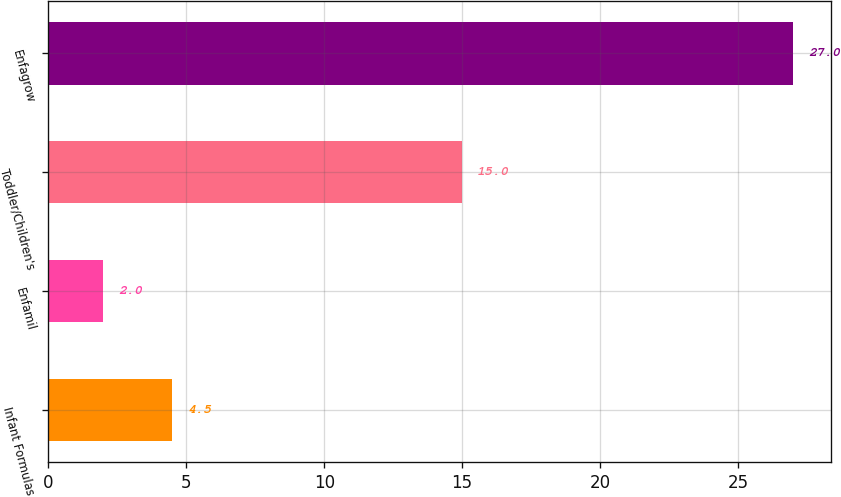Convert chart. <chart><loc_0><loc_0><loc_500><loc_500><bar_chart><fcel>Infant Formulas<fcel>Enfamil<fcel>Toddler/Children's<fcel>Enfagrow<nl><fcel>4.5<fcel>2<fcel>15<fcel>27<nl></chart> 